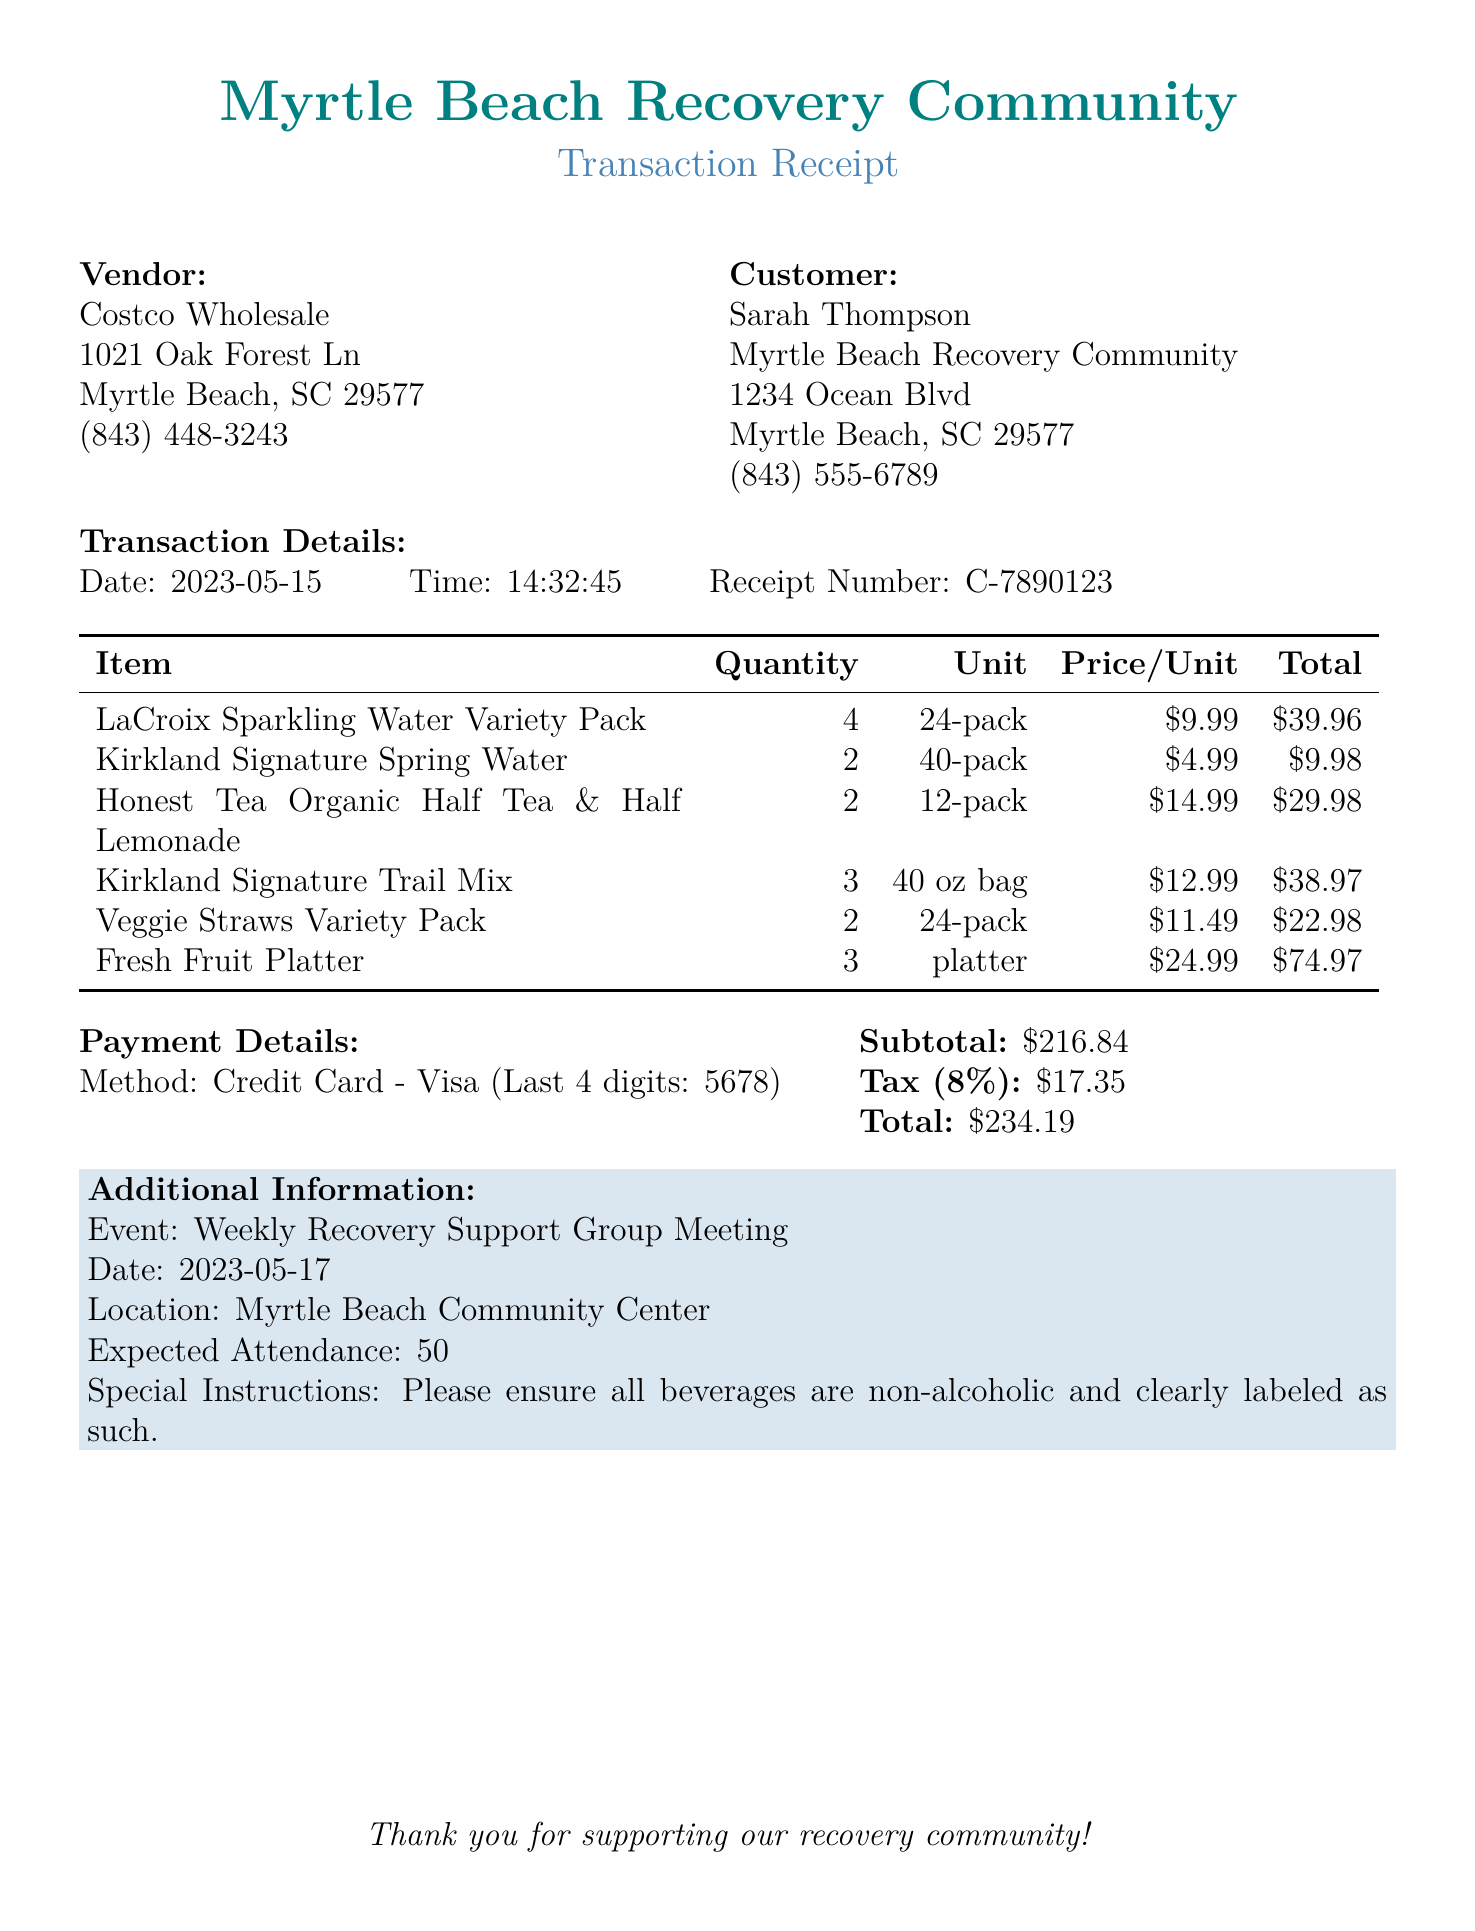What is the name of the vendor? The vendor's name is listed at the top of the document under the vendor section.
Answer: Costco Wholesale What is the date of the transaction? The date is stated in the transaction details section of the document.
Answer: 2023-05-15 What is the total amount spent? The total amount is provided in the payment details section at the end of the document.
Answer: $234.19 How many Fresh Fruit Platters were purchased? The quantity is specified in the items list within the document.
Answer: 3 What special instructions were given for the event? The special instructions are mentioned in the additional information section.
Answer: Please ensure all beverages are non-alcoholic and clearly labeled as such What is the expected attendance for the meeting? The expected attendance figure is provided in the additional information section of the document.
Answer: 50 What is the name of the customer? The customer's name is clearly identified in the customer section of the document.
Answer: Sarah Thompson What methods of payment was used? The payment method is mentioned in the payment details part of the document.
Answer: Credit Card - Visa (Last 4 digits: 5678) 